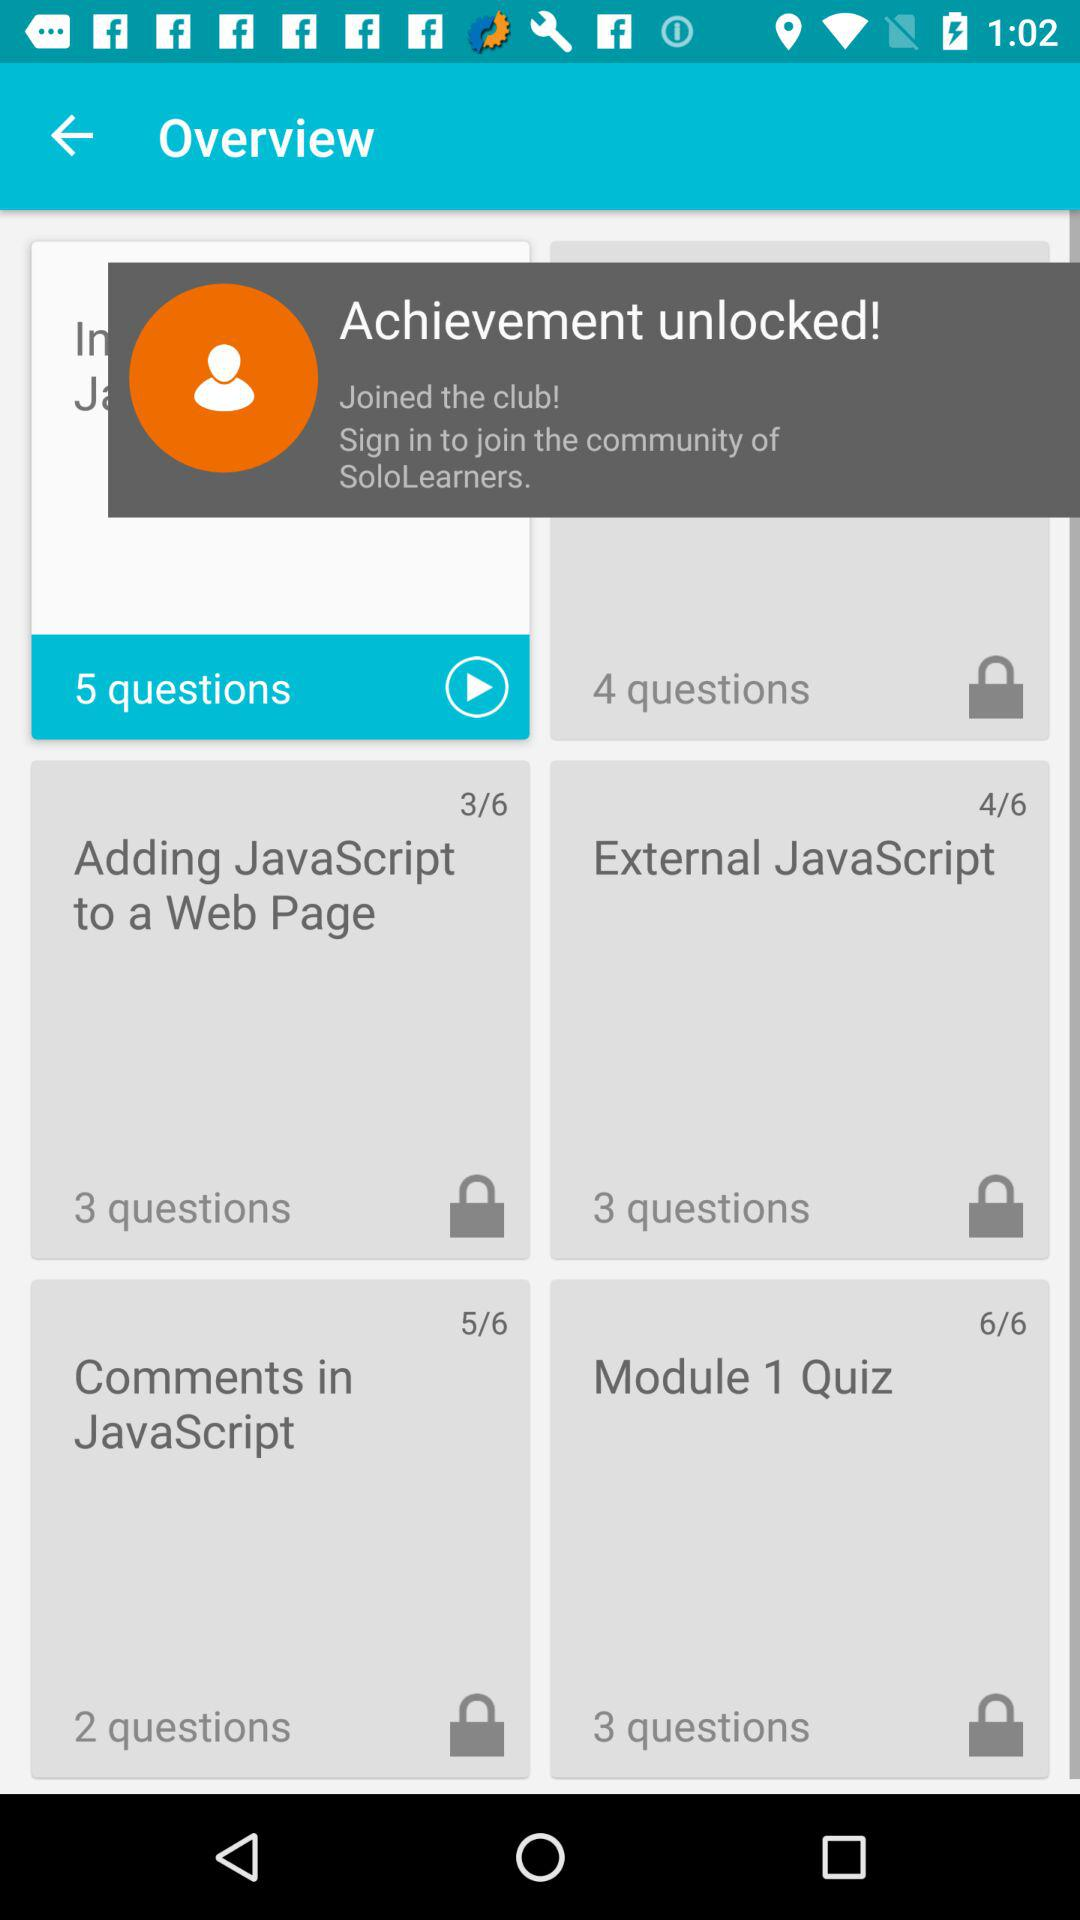How many questions are there in "Adding JavaScript to a Web Page"? There are 3 questions. 